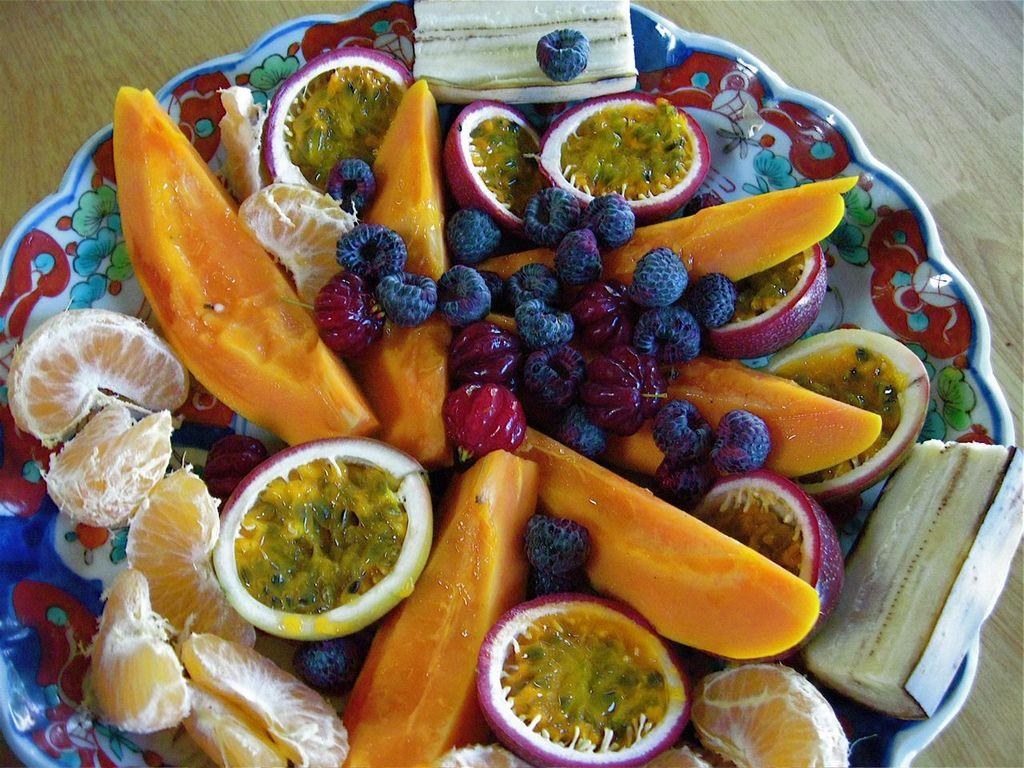What is in the center of the image? There is a plate in the center of the image. What is on the plate? The plate contains different types of fruits. What can be seen in the background of the image? There is a wooden table in the background of the image. Can you tell me how many roses are on the plate? There are no roses present on the plate; it contains different types of fruits. Is there a judge sitting at the table in the image? There is no judge present in the image; it only features a plate of fruits on a wooden table. 